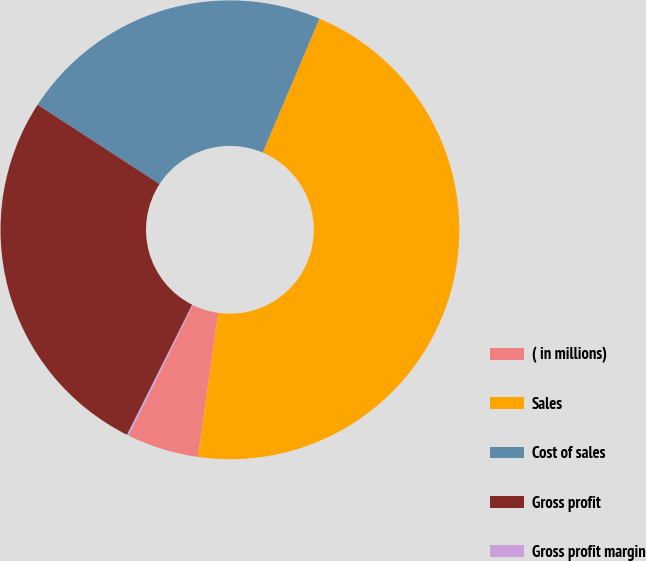Convert chart to OTSL. <chart><loc_0><loc_0><loc_500><loc_500><pie_chart><fcel>( in millions)<fcel>Sales<fcel>Cost of sales<fcel>Gross profit<fcel>Gross profit margin<nl><fcel>5.05%<fcel>45.84%<fcel>22.21%<fcel>26.78%<fcel>0.13%<nl></chart> 